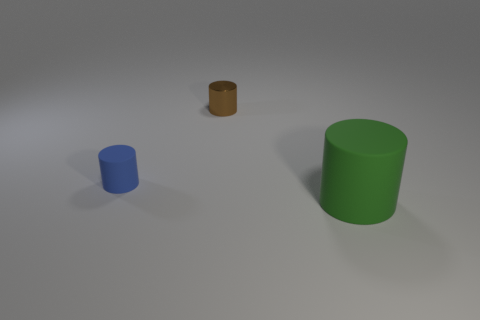What are the colors of the objects displayed? The objects in this image are blue, green, and brown.  Could you tell me the shapes of the objects? Certainly! There's a blue cylinder with a smaller diameter, a green cylinder with a larger diameter, and a brown object that appears to be a short cylinder or a disk. 